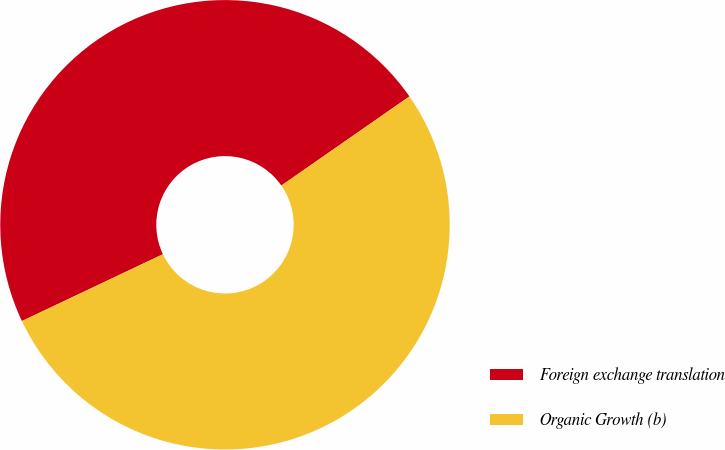<chart> <loc_0><loc_0><loc_500><loc_500><pie_chart><fcel>Foreign exchange translation<fcel>Organic Growth (b)<nl><fcel>47.37%<fcel>52.63%<nl></chart> 